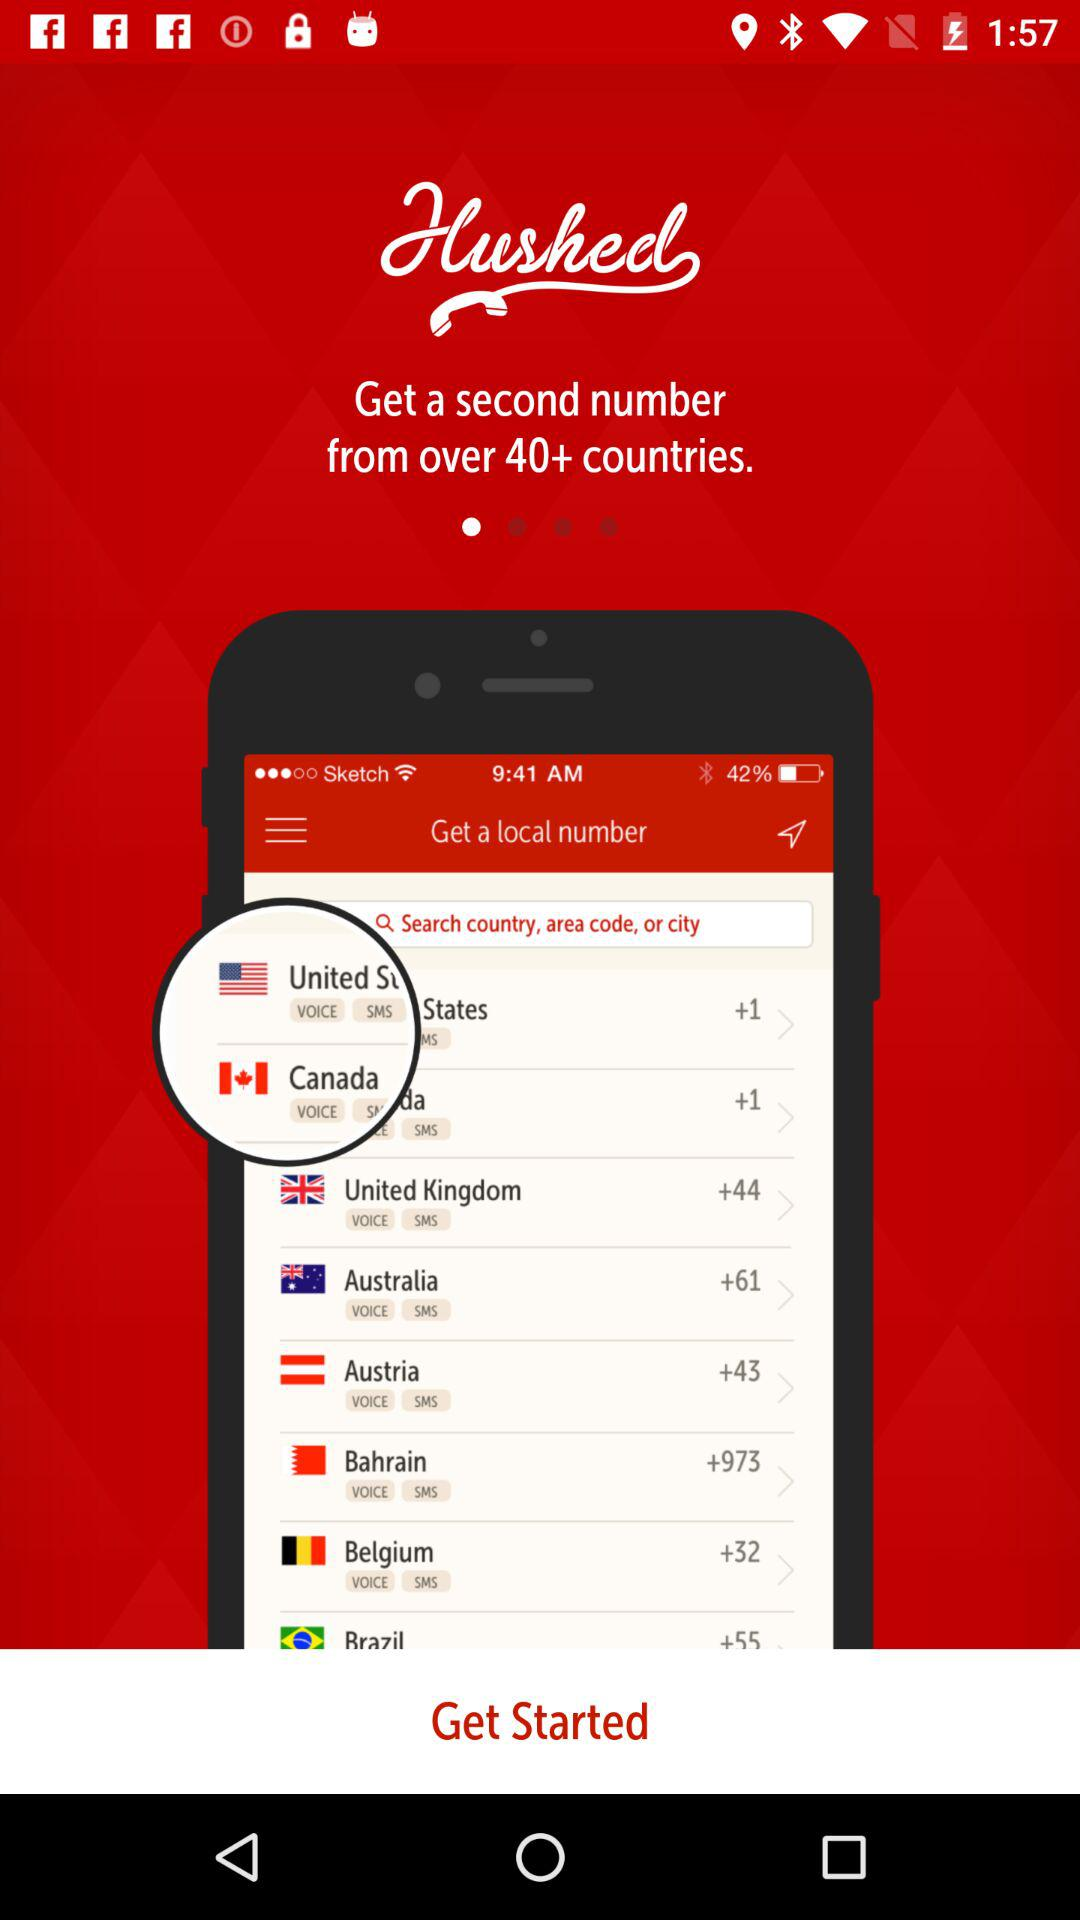What is the country code for Australia? The country code for Australia is +61. 